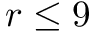Convert formula to latex. <formula><loc_0><loc_0><loc_500><loc_500>r \leq 9</formula> 